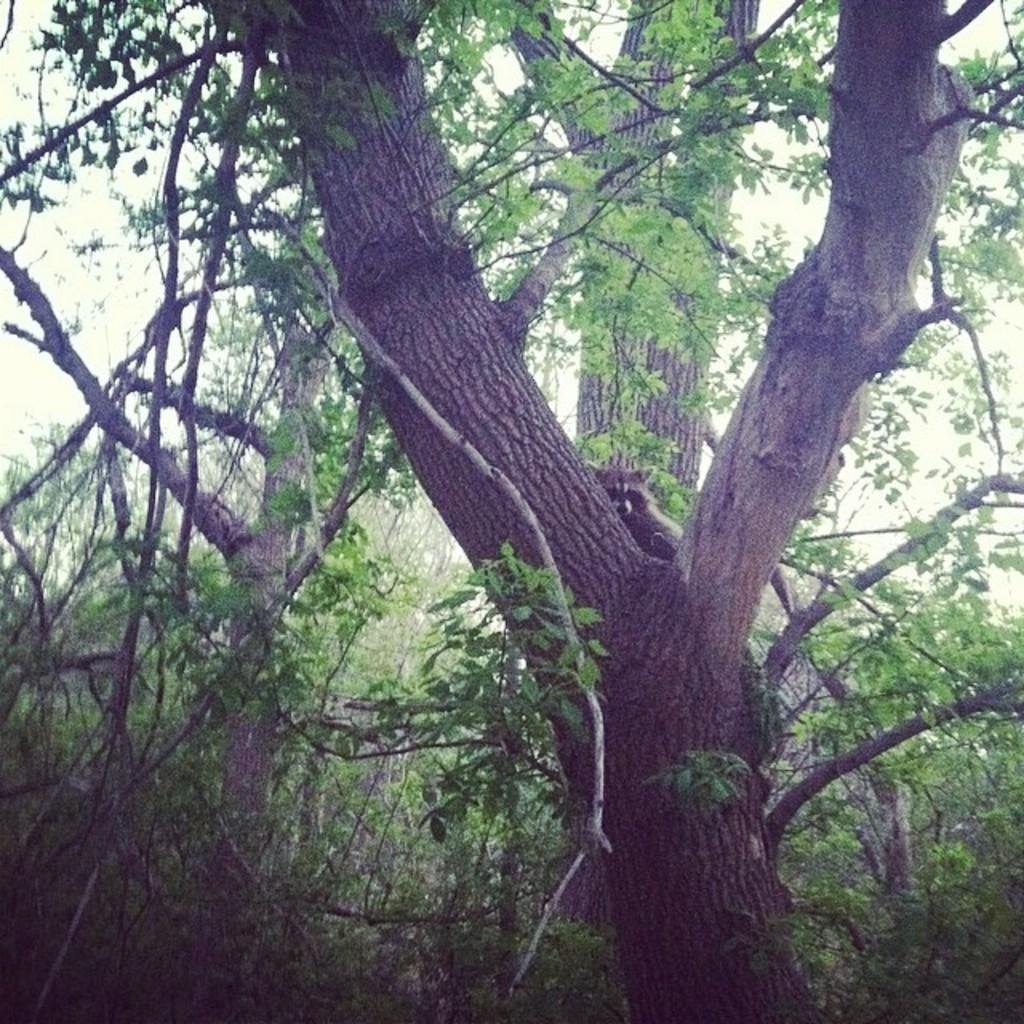What type of vegetation is present in the image? The image contains trees and plants. Can you describe the trees in the image? Unfortunately, the facts provided do not give specific details about the trees. How many types of vegetation are present in the image? There are two types of vegetation present in the image: trees and plants. What type of bottle can be seen hanging from the tree in the image? There is no bottle present in the image; it only contains trees and plants. How many beads are visible on the plants in the image? There are no beads present on the plants in the image. 